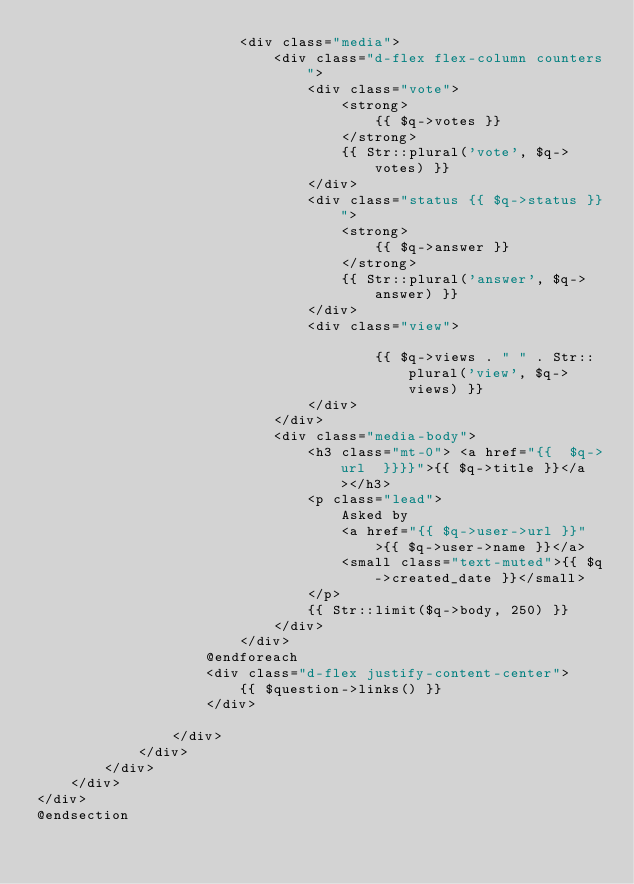Convert code to text. <code><loc_0><loc_0><loc_500><loc_500><_PHP_>                        <div class="media">
                            <div class="d-flex flex-column counters">
                                <div class="vote">
                                    <strong>
                                        {{ $q->votes }}
                                    </strong>
                                    {{ Str::plural('vote', $q->votes) }}
                                </div>
                                <div class="status {{ $q->status }}">
                                    <strong>
                                        {{ $q->answer }}
                                    </strong>
                                    {{ Str::plural('answer', $q->answer) }}
                                </div>
                                <div class="view">
                                    
                                        {{ $q->views . " " . Str::plural('view', $q->views) }}
                                </div>
                            </div>
                            <div class="media-body">
                                <h3 class="mt-0"> <a href="{{  $q->url  }}}}">{{ $q->title }}</a></h3>
                                <p class="lead">
                                    Asked by
                                    <a href="{{ $q->user->url }}">{{ $q->user->name }}</a>
                                    <small class="text-muted">{{ $q->created_date }}</small>
                                </p>
                                {{ Str::limit($q->body, 250) }}
                            </div>
                        </div>
                    @endforeach
                    <div class="d-flex justify-content-center">
                        {{ $question->links() }}
                    </div>
                    
                </div>
            </div>
        </div>
    </div>
</div>
@endsection
</code> 